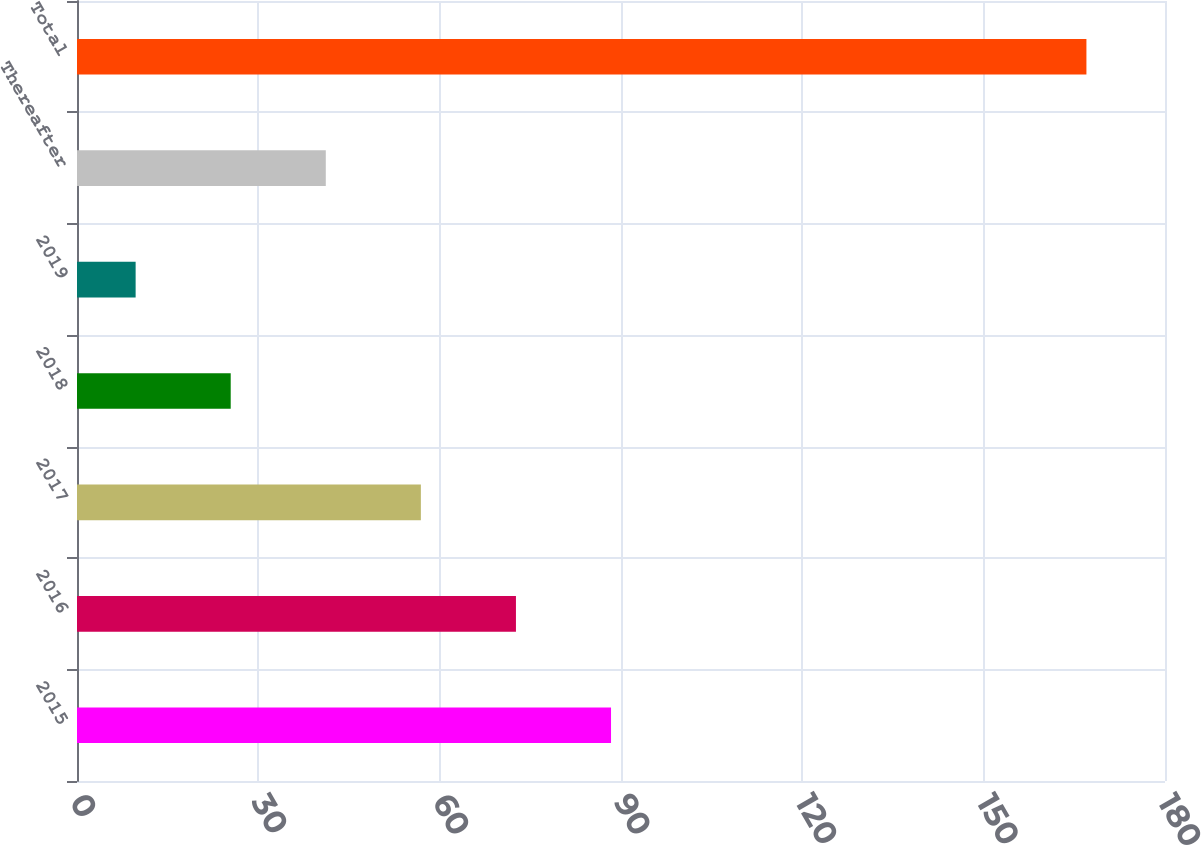Convert chart to OTSL. <chart><loc_0><loc_0><loc_500><loc_500><bar_chart><fcel>2015<fcel>2016<fcel>2017<fcel>2018<fcel>2019<fcel>Thereafter<fcel>Total<nl><fcel>88.35<fcel>72.62<fcel>56.89<fcel>25.43<fcel>9.7<fcel>41.16<fcel>167<nl></chart> 